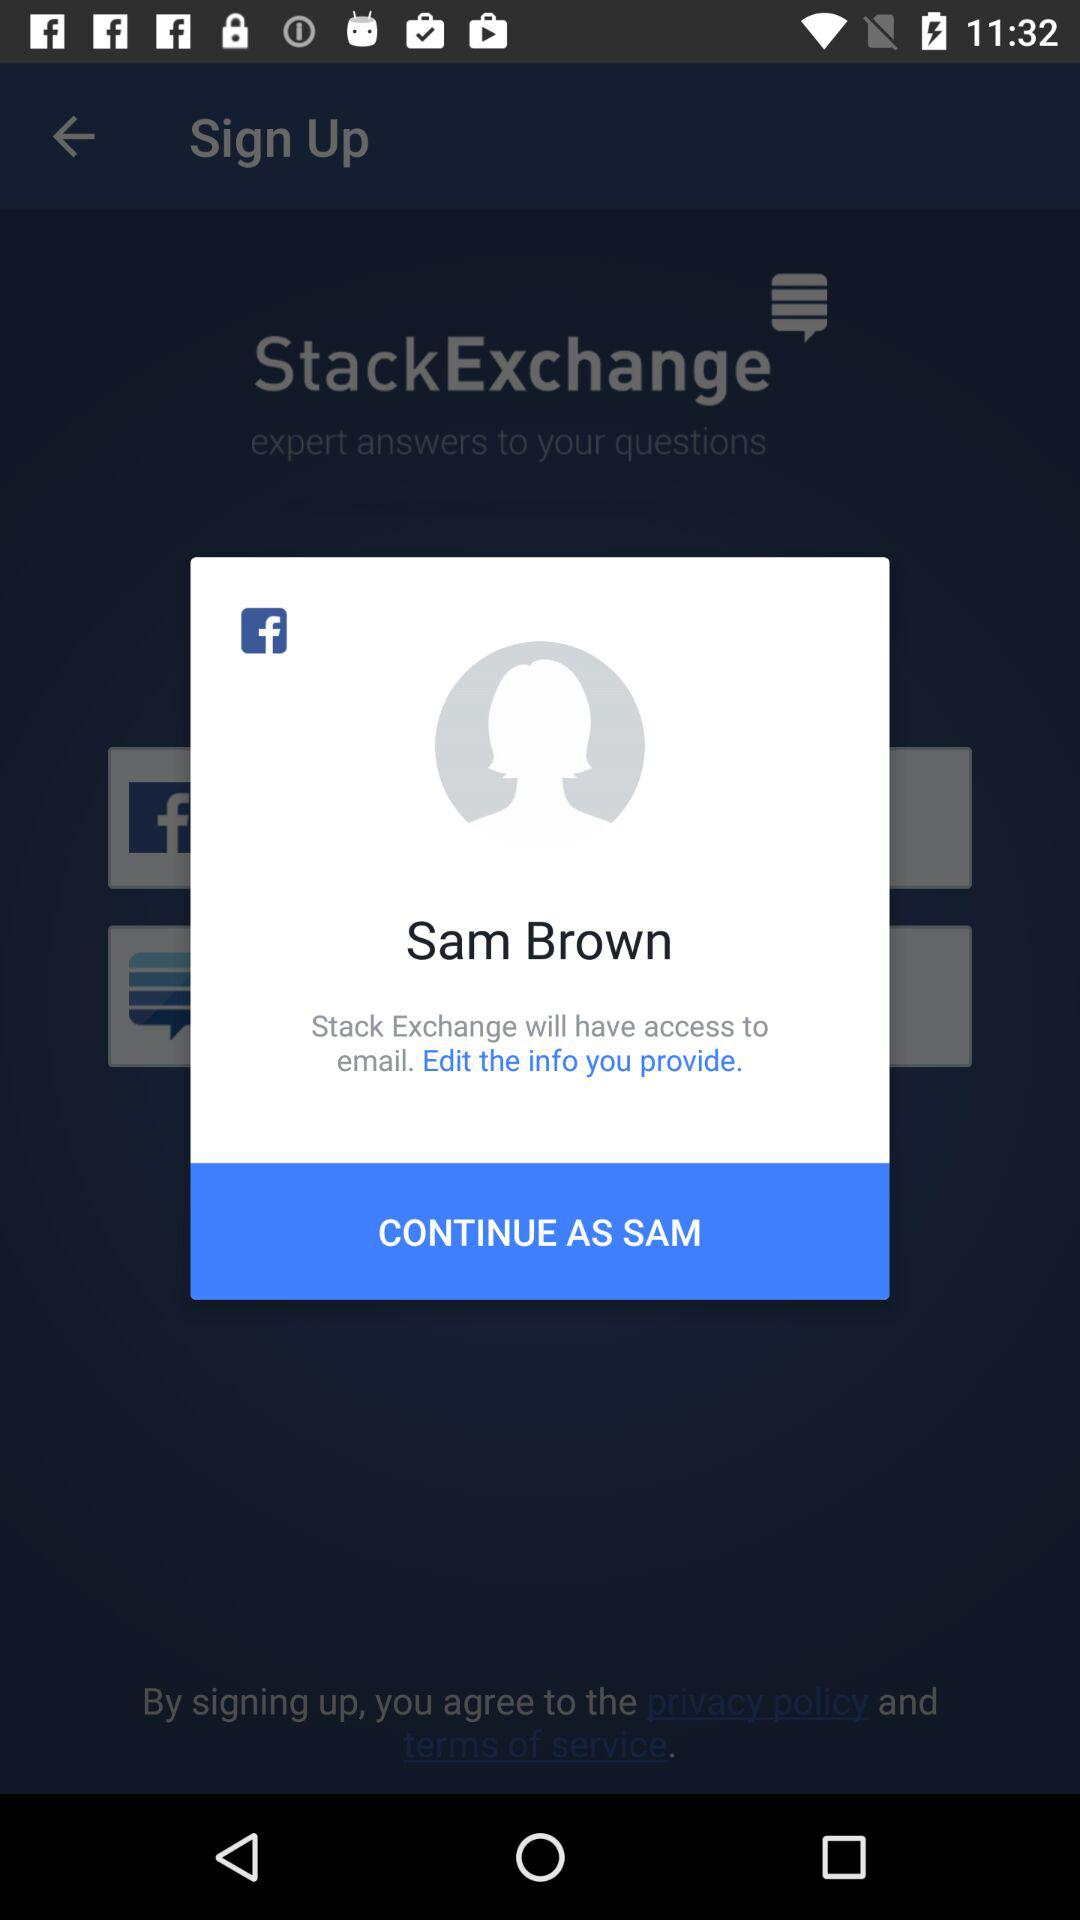What is the name of the user? The name of the user is Sam Brown. 